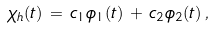Convert formula to latex. <formula><loc_0><loc_0><loc_500><loc_500>\chi _ { h } ( t ) \, = \, c _ { 1 } \phi _ { 1 } ( t ) \, + \, c _ { 2 } \phi _ { 2 } ( t ) \, ,</formula> 